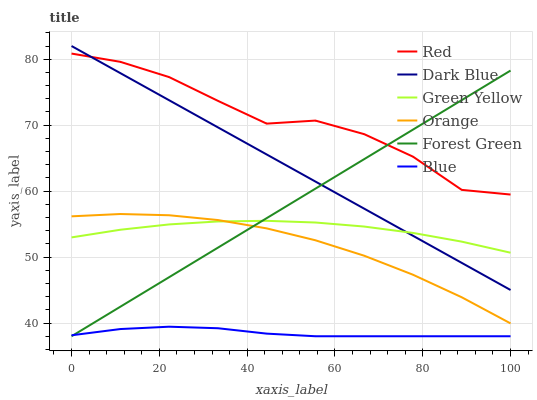Does Blue have the minimum area under the curve?
Answer yes or no. Yes. Does Red have the maximum area under the curve?
Answer yes or no. Yes. Does Dark Blue have the minimum area under the curve?
Answer yes or no. No. Does Dark Blue have the maximum area under the curve?
Answer yes or no. No. Is Forest Green the smoothest?
Answer yes or no. Yes. Is Red the roughest?
Answer yes or no. Yes. Is Dark Blue the smoothest?
Answer yes or no. No. Is Dark Blue the roughest?
Answer yes or no. No. Does Dark Blue have the lowest value?
Answer yes or no. No. Does Forest Green have the highest value?
Answer yes or no. No. Is Orange less than Dark Blue?
Answer yes or no. Yes. Is Red greater than Green Yellow?
Answer yes or no. Yes. Does Orange intersect Dark Blue?
Answer yes or no. No. 